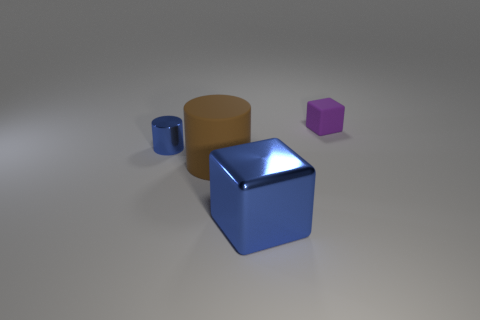What number of things are either objects to the left of the big brown matte thing or purple rubber things behind the big matte object?
Provide a succinct answer. 2. Do the matte cylinder and the metallic cylinder have the same color?
Provide a succinct answer. No. Are there fewer blue blocks than big cyan spheres?
Ensure brevity in your answer.  No. There is a blue cube; are there any big metallic blocks behind it?
Give a very brief answer. No. Is the material of the blue cube the same as the purple object?
Give a very brief answer. No. What color is the metallic object that is the same shape as the large rubber thing?
Keep it short and to the point. Blue. There is a small metal object on the left side of the purple block; is its color the same as the large matte cylinder?
Give a very brief answer. No. There is a shiny object that is the same color as the small cylinder; what is its shape?
Your answer should be very brief. Cube. How many brown cylinders have the same material as the purple block?
Your answer should be compact. 1. What number of shiny cylinders are on the left side of the metal cylinder?
Provide a short and direct response. 0. 